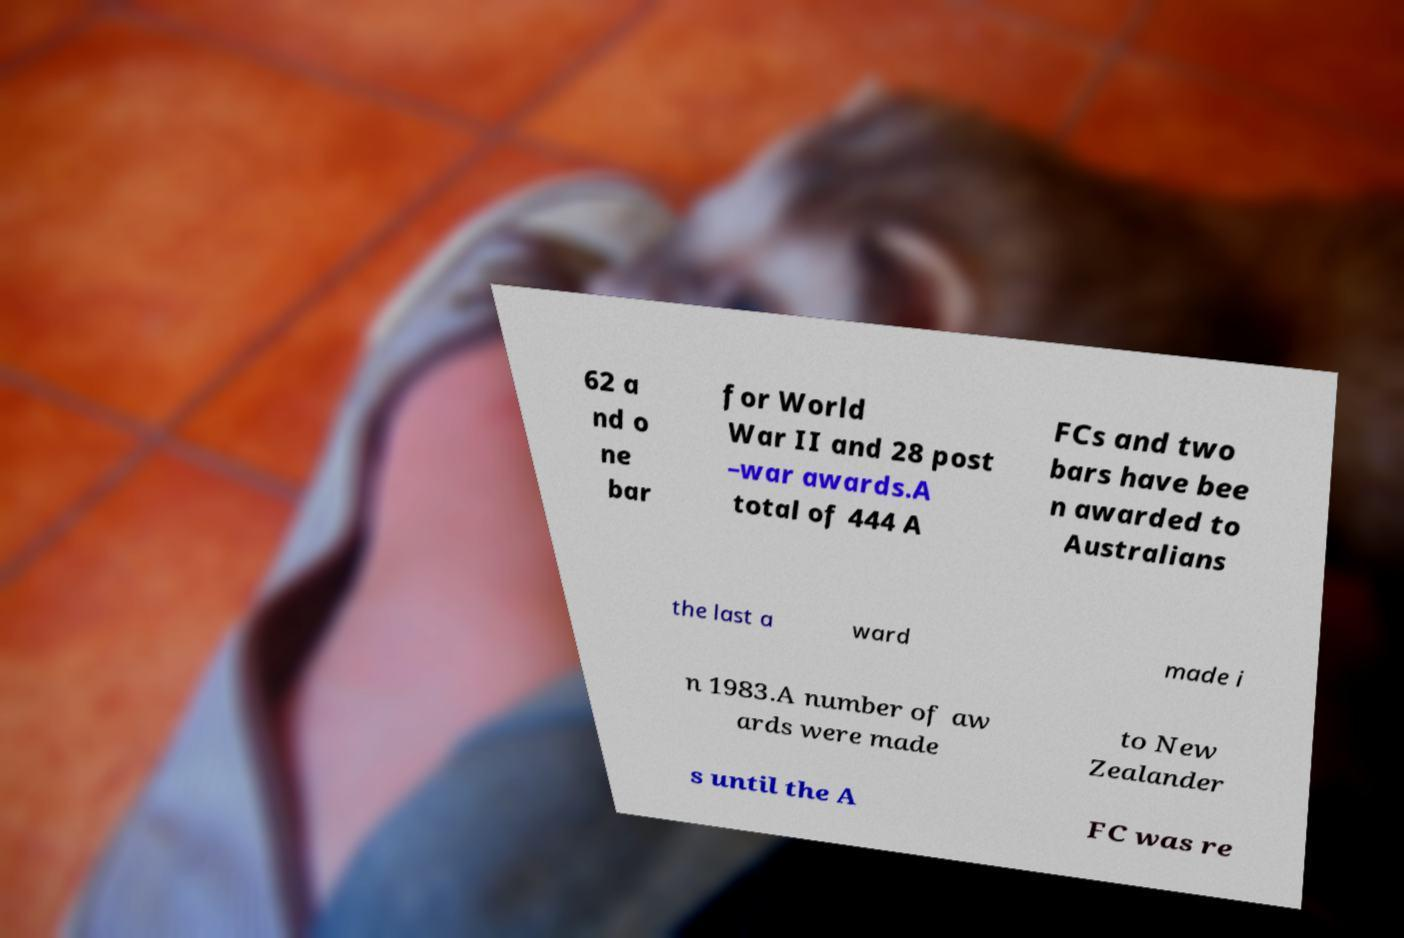Please read and relay the text visible in this image. What does it say? 62 a nd o ne bar for World War II and 28 post –war awards.A total of 444 A FCs and two bars have bee n awarded to Australians the last a ward made i n 1983.A number of aw ards were made to New Zealander s until the A FC was re 